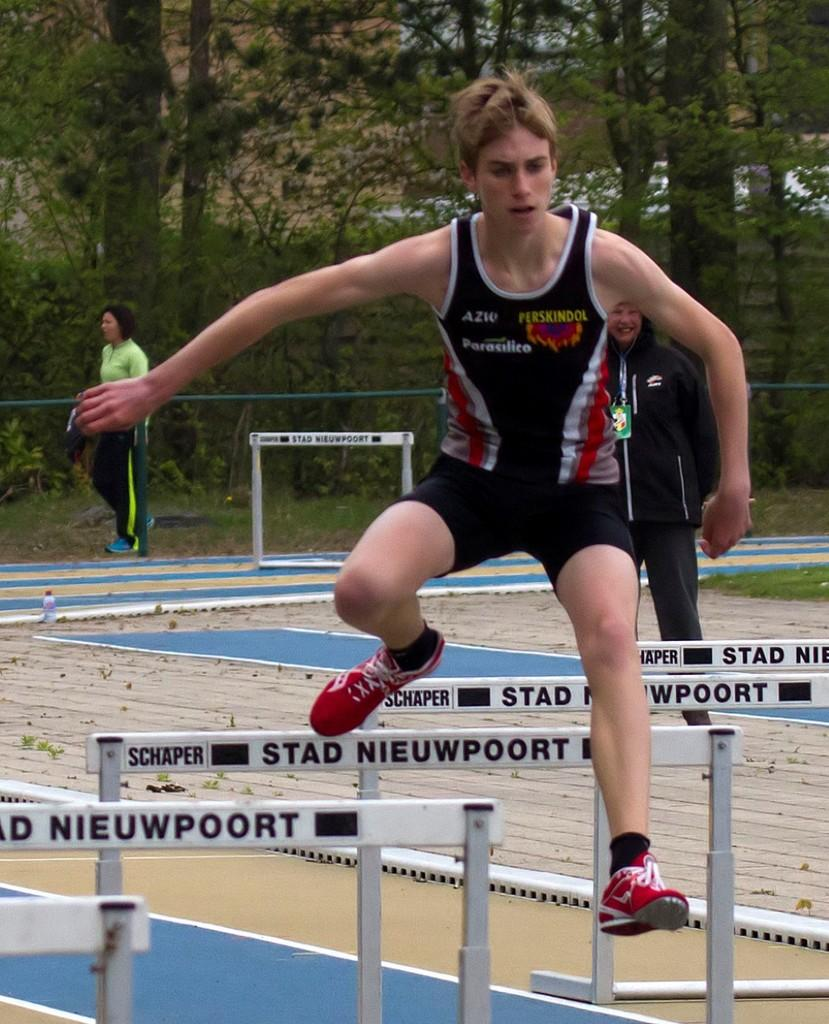<image>
Relay a brief, clear account of the picture shown. A male athlete jumps hurdles with the name Schaper Stad Nieuwpoort on them. 